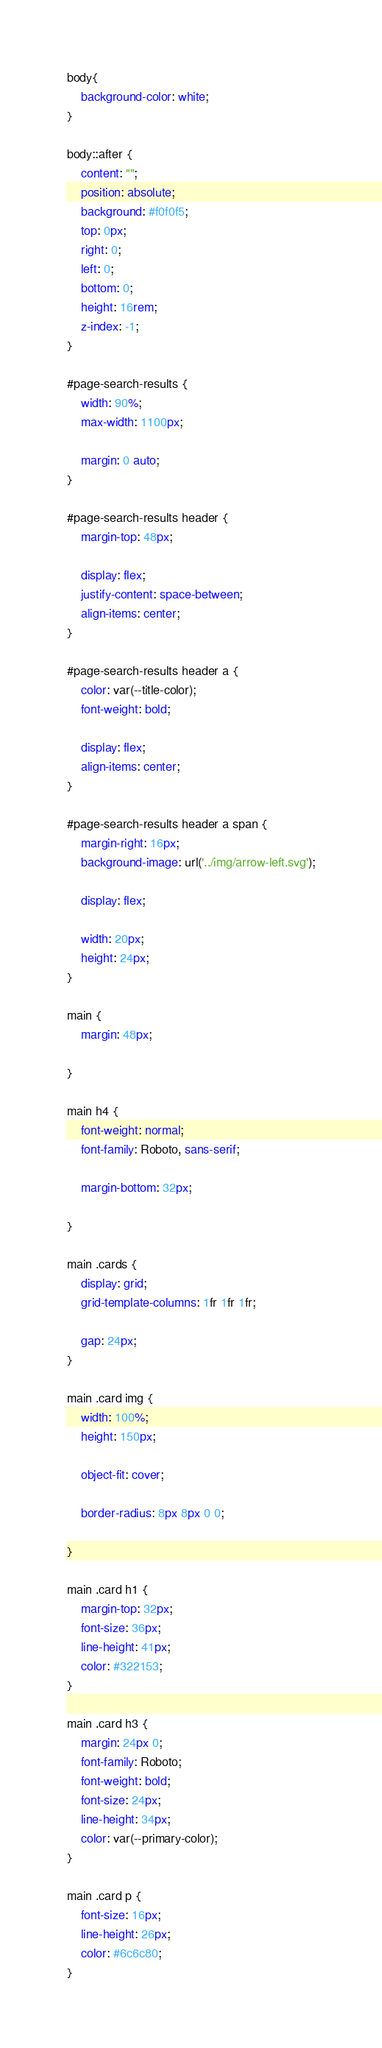<code> <loc_0><loc_0><loc_500><loc_500><_CSS_>body{
    background-color: white;
}

body::after {
    content: "";
    position: absolute;
    background: #f0f0f5;
    top: 0px;
    right: 0;
    left: 0;
    bottom: 0;
    height: 16rem;
    z-index: -1;
}

#page-search-results {
    width: 90%;
    max-width: 1100px;

    margin: 0 auto;
}

#page-search-results header {
    margin-top: 48px;

    display: flex;
    justify-content: space-between;
    align-items: center;
}

#page-search-results header a {
    color: var(--title-color);
    font-weight: bold;

    display: flex;
    align-items: center;
}

#page-search-results header a span {
    margin-right: 16px;
    background-image: url('../img/arrow-left.svg');
    
    display: flex;

    width: 20px;
    height: 24px;
}

main {
    margin: 48px;

}

main h4 {
    font-weight: normal;
    font-family: Roboto, sans-serif;

    margin-bottom: 32px;
    
}

main .cards {
    display: grid;
    grid-template-columns: 1fr 1fr 1fr;

    gap: 24px;
}

main .card img {
    width: 100%;
    height: 150px;

    object-fit: cover;

    border-radius: 8px 8px 0 0;

}

main .card h1 {
    margin-top: 32px;
    font-size: 36px;
    line-height: 41px;
    color: #322153;
}

main .card h3 {
    margin: 24px 0;
    font-family: Roboto;
    font-weight: bold;
    font-size: 24px;
    line-height: 34px;
    color: var(--primary-color);
}

main .card p {
    font-size: 16px;
    line-height: 26px;
    color: #6c6c80;
}</code> 